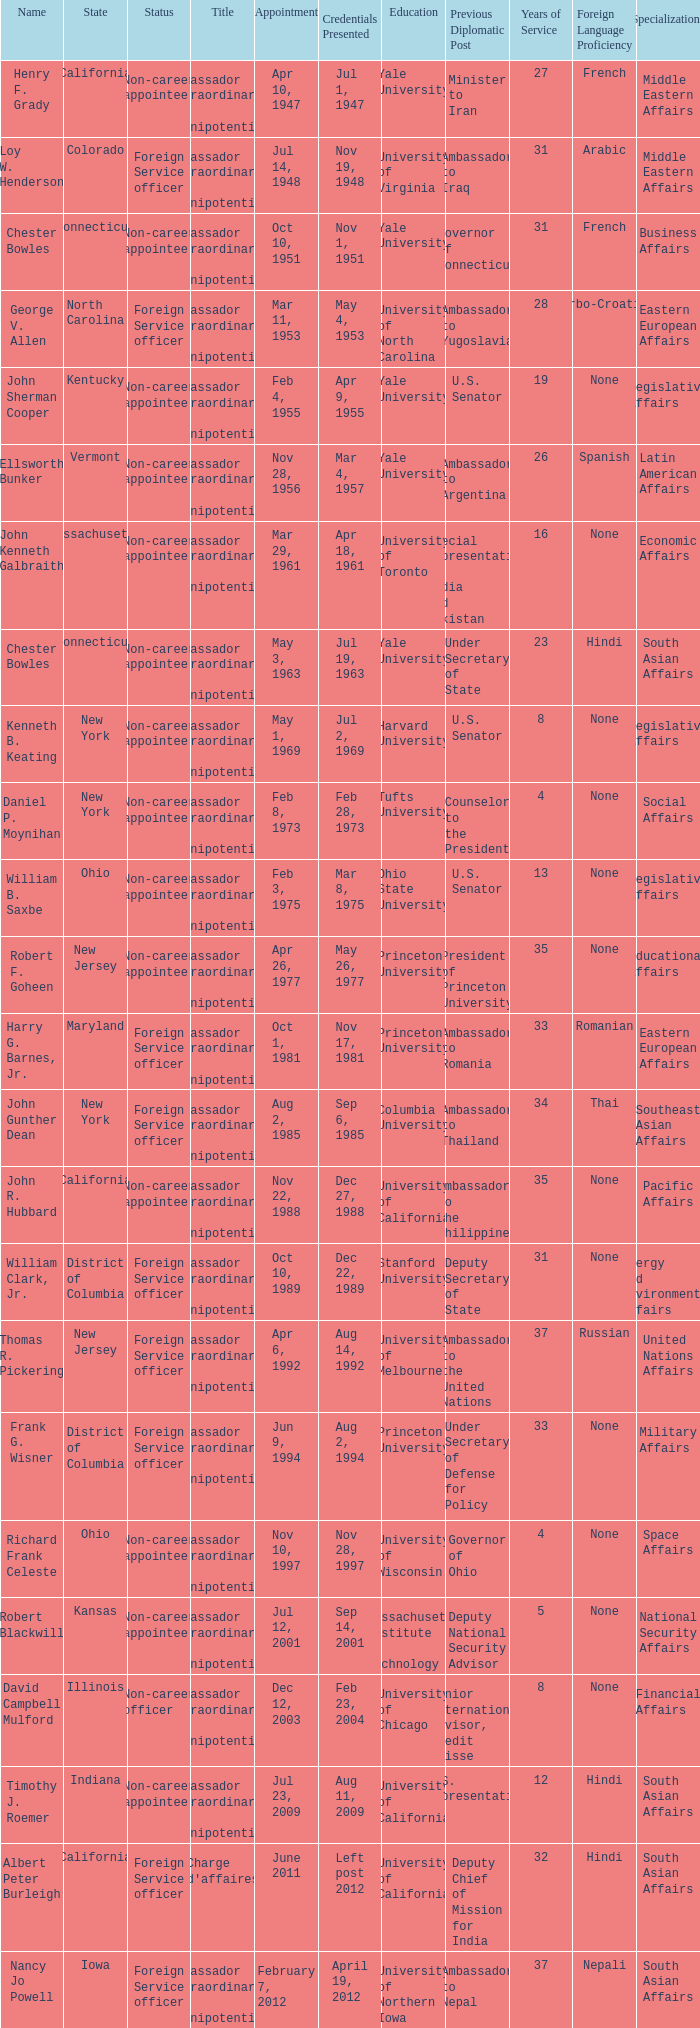When were the credentials presented for new jersey with a status of foreign service officer? Aug 14, 1992. 